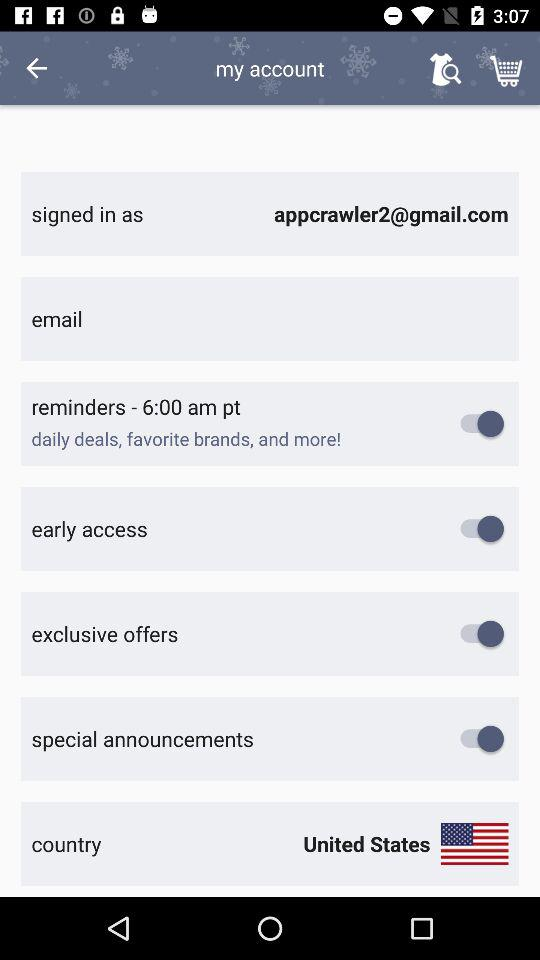What's the Google mail address? The Google mail address is appcrawler2@gmail.com. 